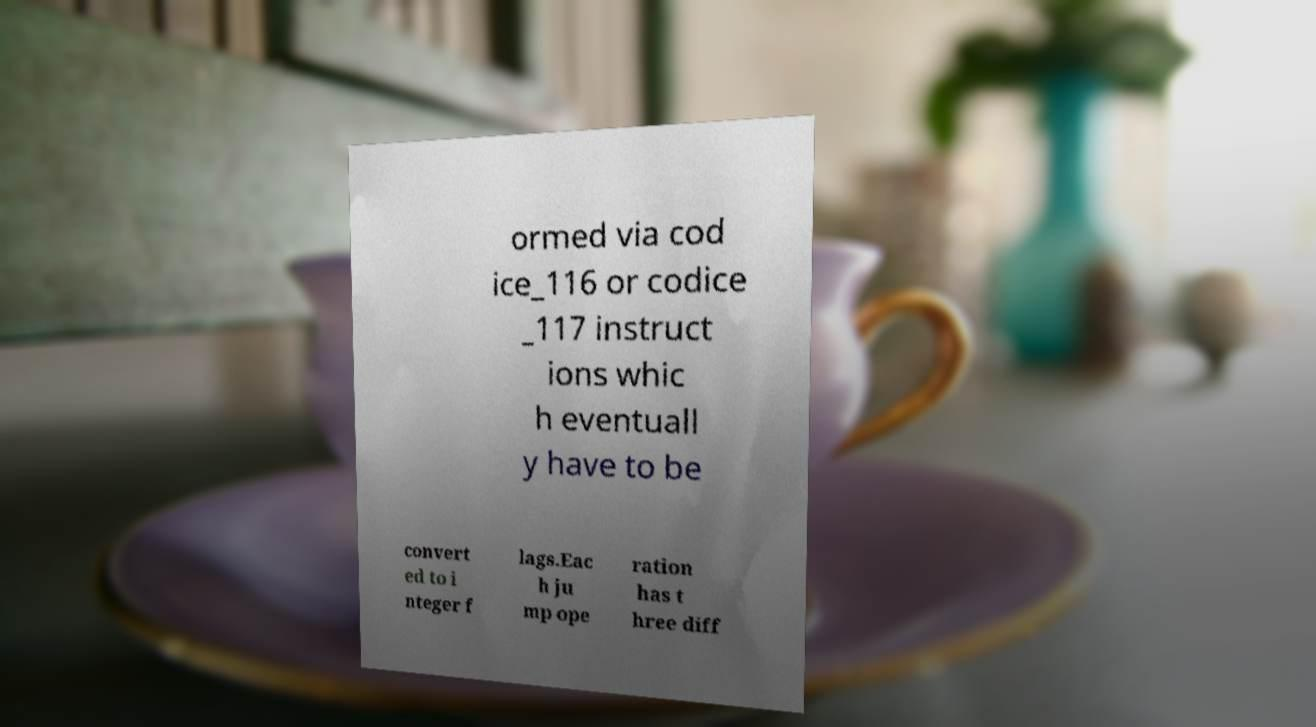There's text embedded in this image that I need extracted. Can you transcribe it verbatim? ormed via cod ice_116 or codice _117 instruct ions whic h eventuall y have to be convert ed to i nteger f lags.Eac h ju mp ope ration has t hree diff 